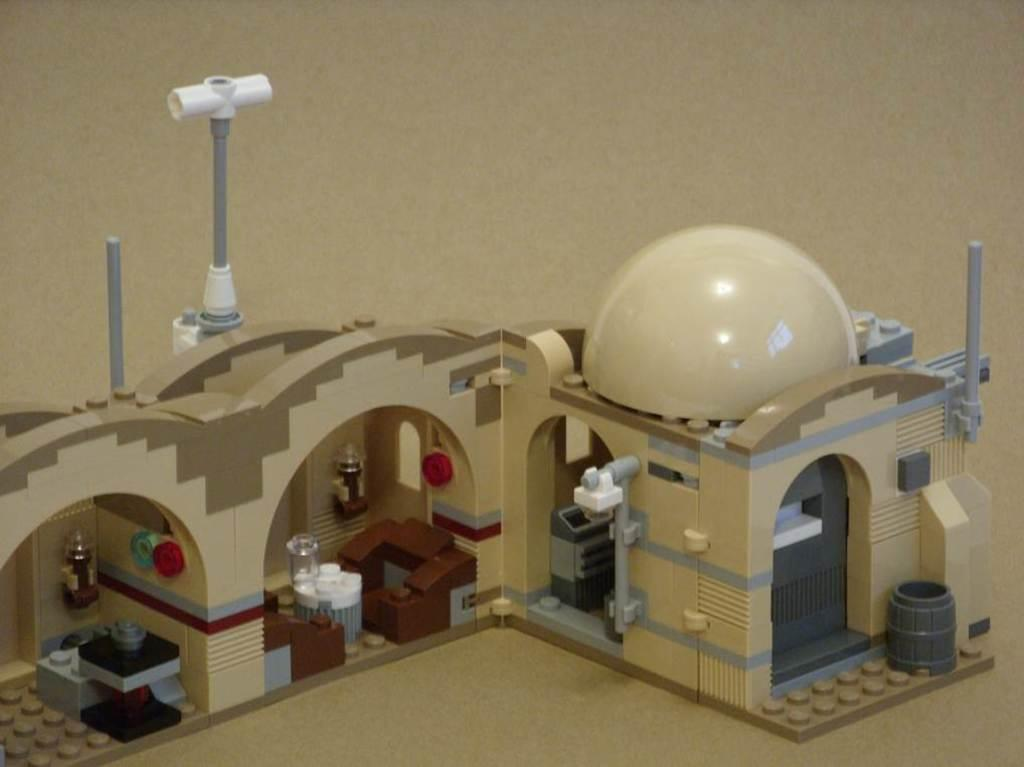What is the main object in the image? There is a toy house in the image. Is the toy house placed on any surface? Yes, the toy house is on a platform. What color is the background of the image? The background of the image is cream color. How many cows are visible in the image? There are no cows present in the image. What type of chess piece is located on the platform next to the toy house? There is no chess piece present in the image. 